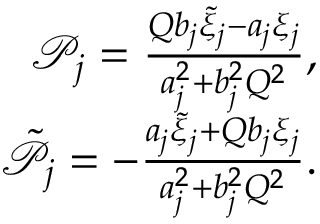<formula> <loc_0><loc_0><loc_500><loc_500>\begin{array} { r } { \mathcal { P } _ { j } = \frac { Q b _ { j } \tilde { \xi } _ { j } - a _ { j } \xi _ { j } } { a _ { j } ^ { 2 } + b _ { j } ^ { 2 } Q ^ { 2 } } , } \\ { \tilde { \mathcal { P } } _ { j } = - \frac { a _ { j } \tilde { \xi } _ { j } + Q b _ { j } \xi _ { j } } { a _ { j } ^ { 2 } + b _ { j } ^ { 2 } Q ^ { 2 } } . } \end{array}</formula> 